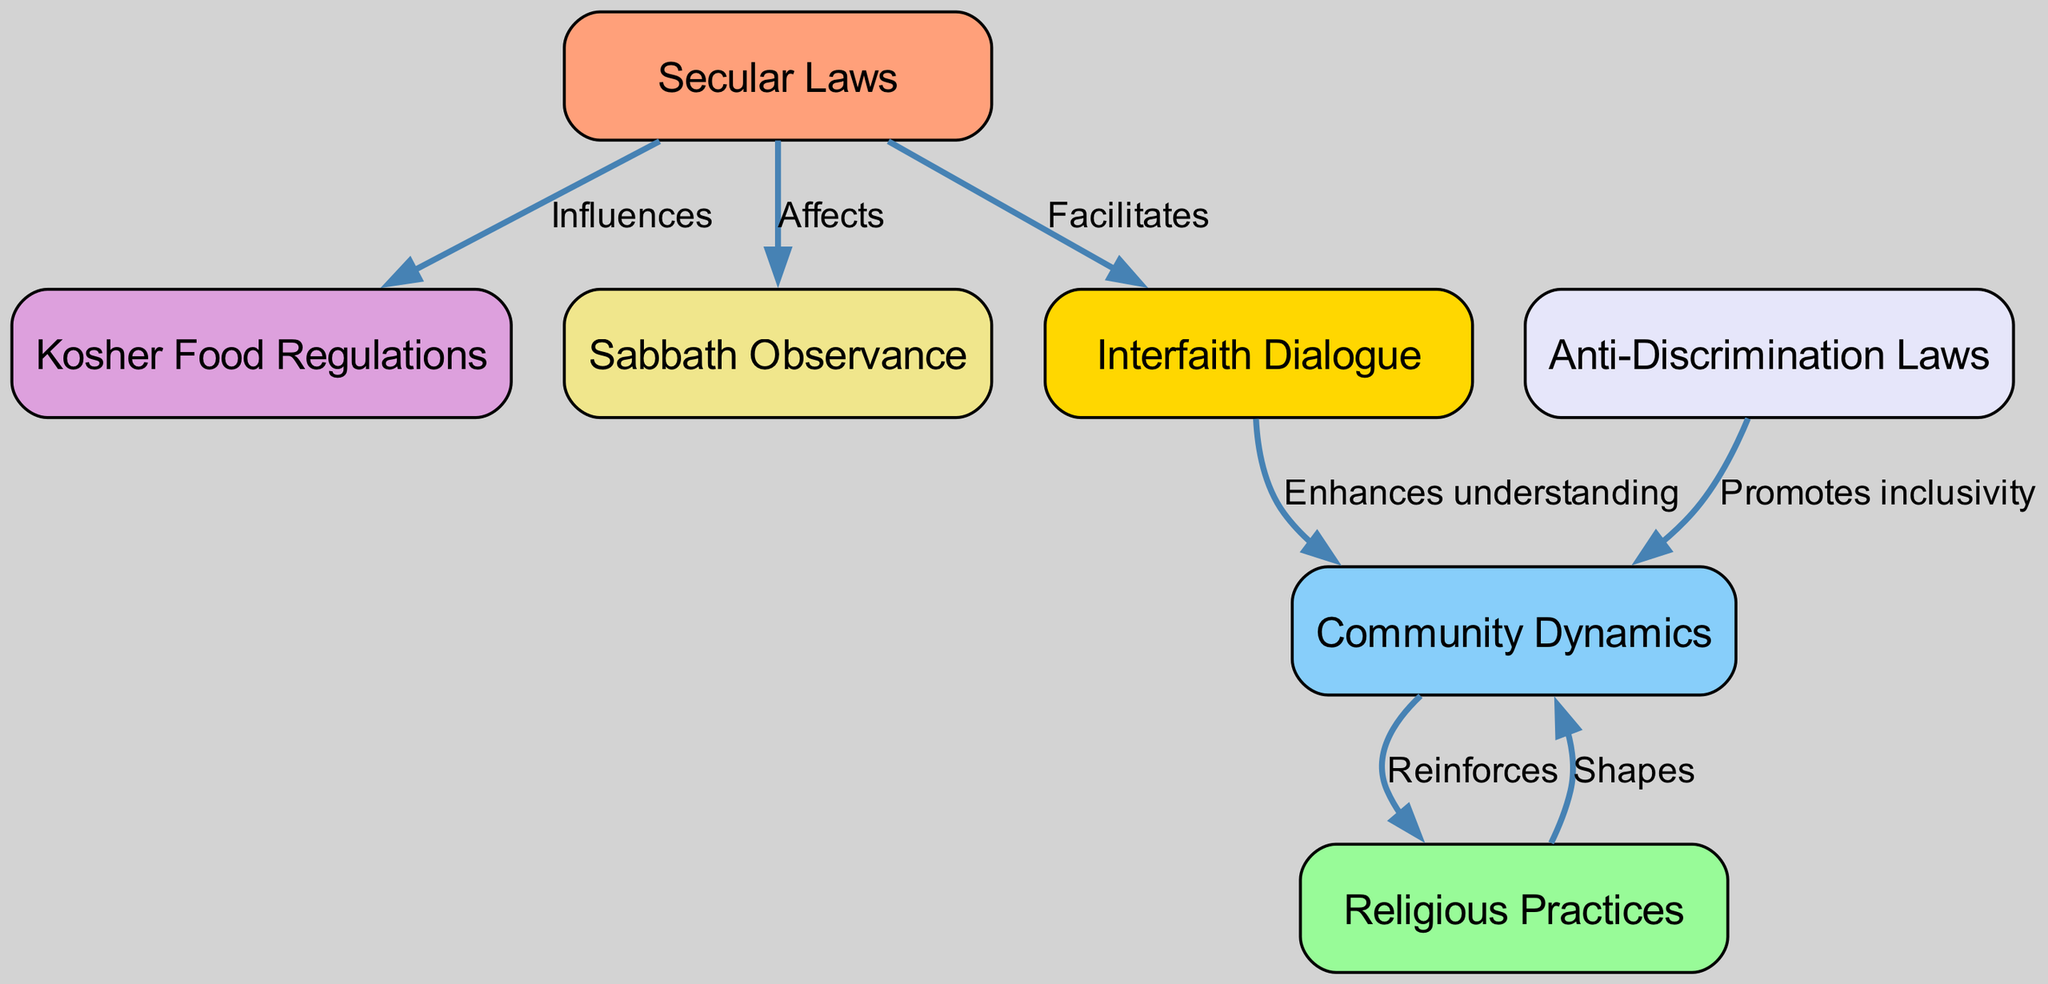What is the total number of nodes in the diagram? The diagram contains seven distinct nodes representing concepts such as Secular Laws, Religious Practices, Community Dynamics, and others. Counting each unique label results in a total of seven nodes.
Answer: 7 What is the relationship between Secular Laws and Kosher Food Regulations? The edge connecting Secular Laws and Kosher Food Regulations is labeled "Influences", indicating that secular laws have an impact on the regulations surrounding kosher food practices.
Answer: Influences What node is influenced by Religious Practices? The edge indicates that Community Dynamics is shaped by Religious Practices, showing that the practices within a religion have a governing effect on how the community operates and interacts.
Answer: Community Dynamics Which law promotes inclusivity within Community Dynamics? The edge between Anti-Discrimination Laws and Community Dynamics is labeled "Promotes inclusivity". This shows that these laws encourage an inclusive atmosphere among community members.
Answer: Anti-Discrimination Laws How many edges connect Secular Laws to other nodes? Secular Laws are connected to three different nodes: Kosher Food Regulations (Influences), Sabbath Observance (Affects), and Interfaith Dialogue (Facilitates). Therefore, there are three edges associated with Secular Laws.
Answer: 3 What kind of relationship exists between Interfaith Dialogue and Community Dynamics? The connection between Interfaith Dialogue and Community Dynamics is labeled "Enhances understanding", which suggests that interfaith dialogue contributes positively in fostering mutual comprehension among community members.
Answer: Enhances understanding How do Religious Practices and Community Dynamics interact? The arrows between Religious Practices and Community Dynamics indicate a bidirectional relationship: Religious Practices shapes Community Dynamics, which in turn reinforces Religious Practices. This indicates a continuous feedback loop between the two.
Answer: Shapes, Reinforces Which two concepts are connected through Anti-Discrimination Laws? Anti-Discrimination Laws are connected to Community Dynamics with a label indicating that they promote inclusivity, demonstrating how legal frameworks influence social behaviors and relationships within a community.
Answer: Community Dynamics 